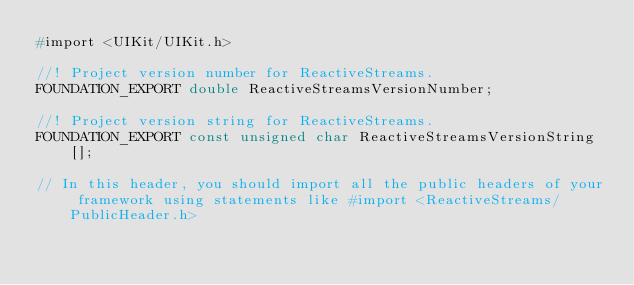<code> <loc_0><loc_0><loc_500><loc_500><_C_>#import <UIKit/UIKit.h>

//! Project version number for ReactiveStreams.
FOUNDATION_EXPORT double ReactiveStreamsVersionNumber;

//! Project version string for ReactiveStreams.
FOUNDATION_EXPORT const unsigned char ReactiveStreamsVersionString[];

// In this header, you should import all the public headers of your framework using statements like #import <ReactiveStreams/PublicHeader.h>


</code> 